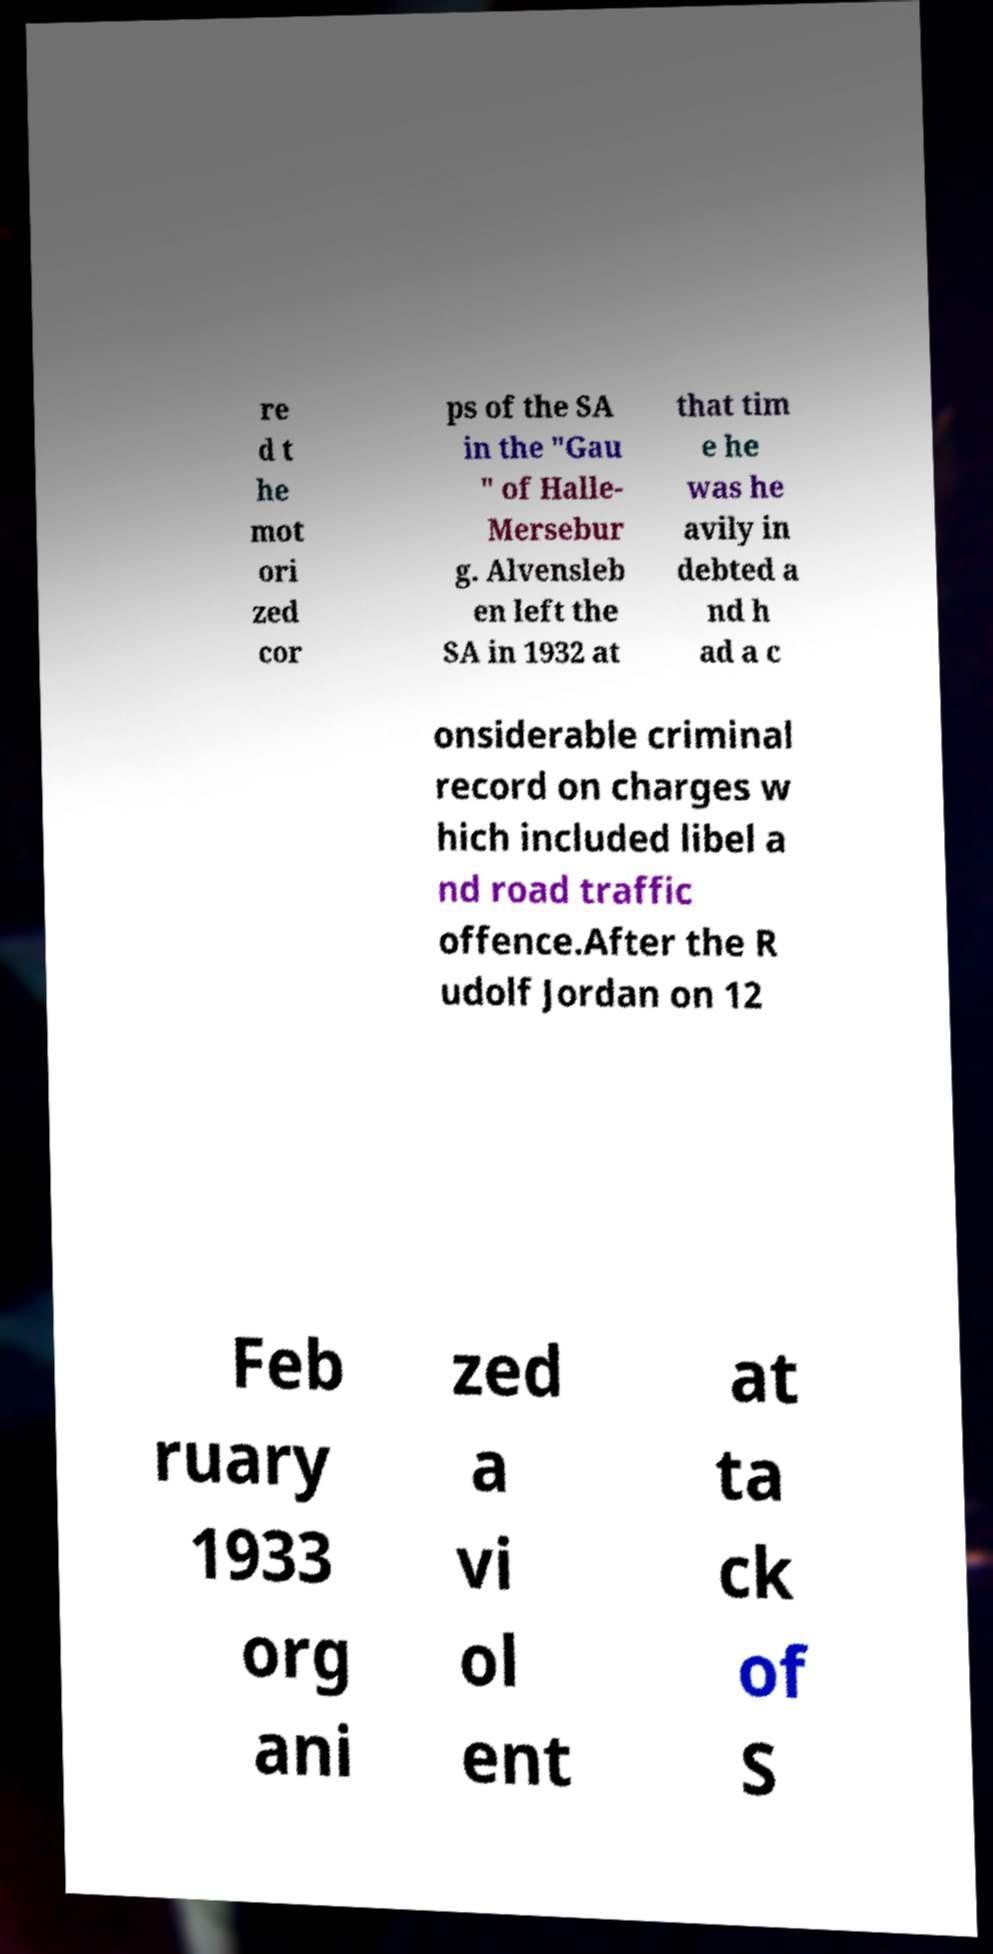Could you assist in decoding the text presented in this image and type it out clearly? re d t he mot ori zed cor ps of the SA in the "Gau " of Halle- Mersebur g. Alvensleb en left the SA in 1932 at that tim e he was he avily in debted a nd h ad a c onsiderable criminal record on charges w hich included libel a nd road traffic offence.After the R udolf Jordan on 12 Feb ruary 1933 org ani zed a vi ol ent at ta ck of S 